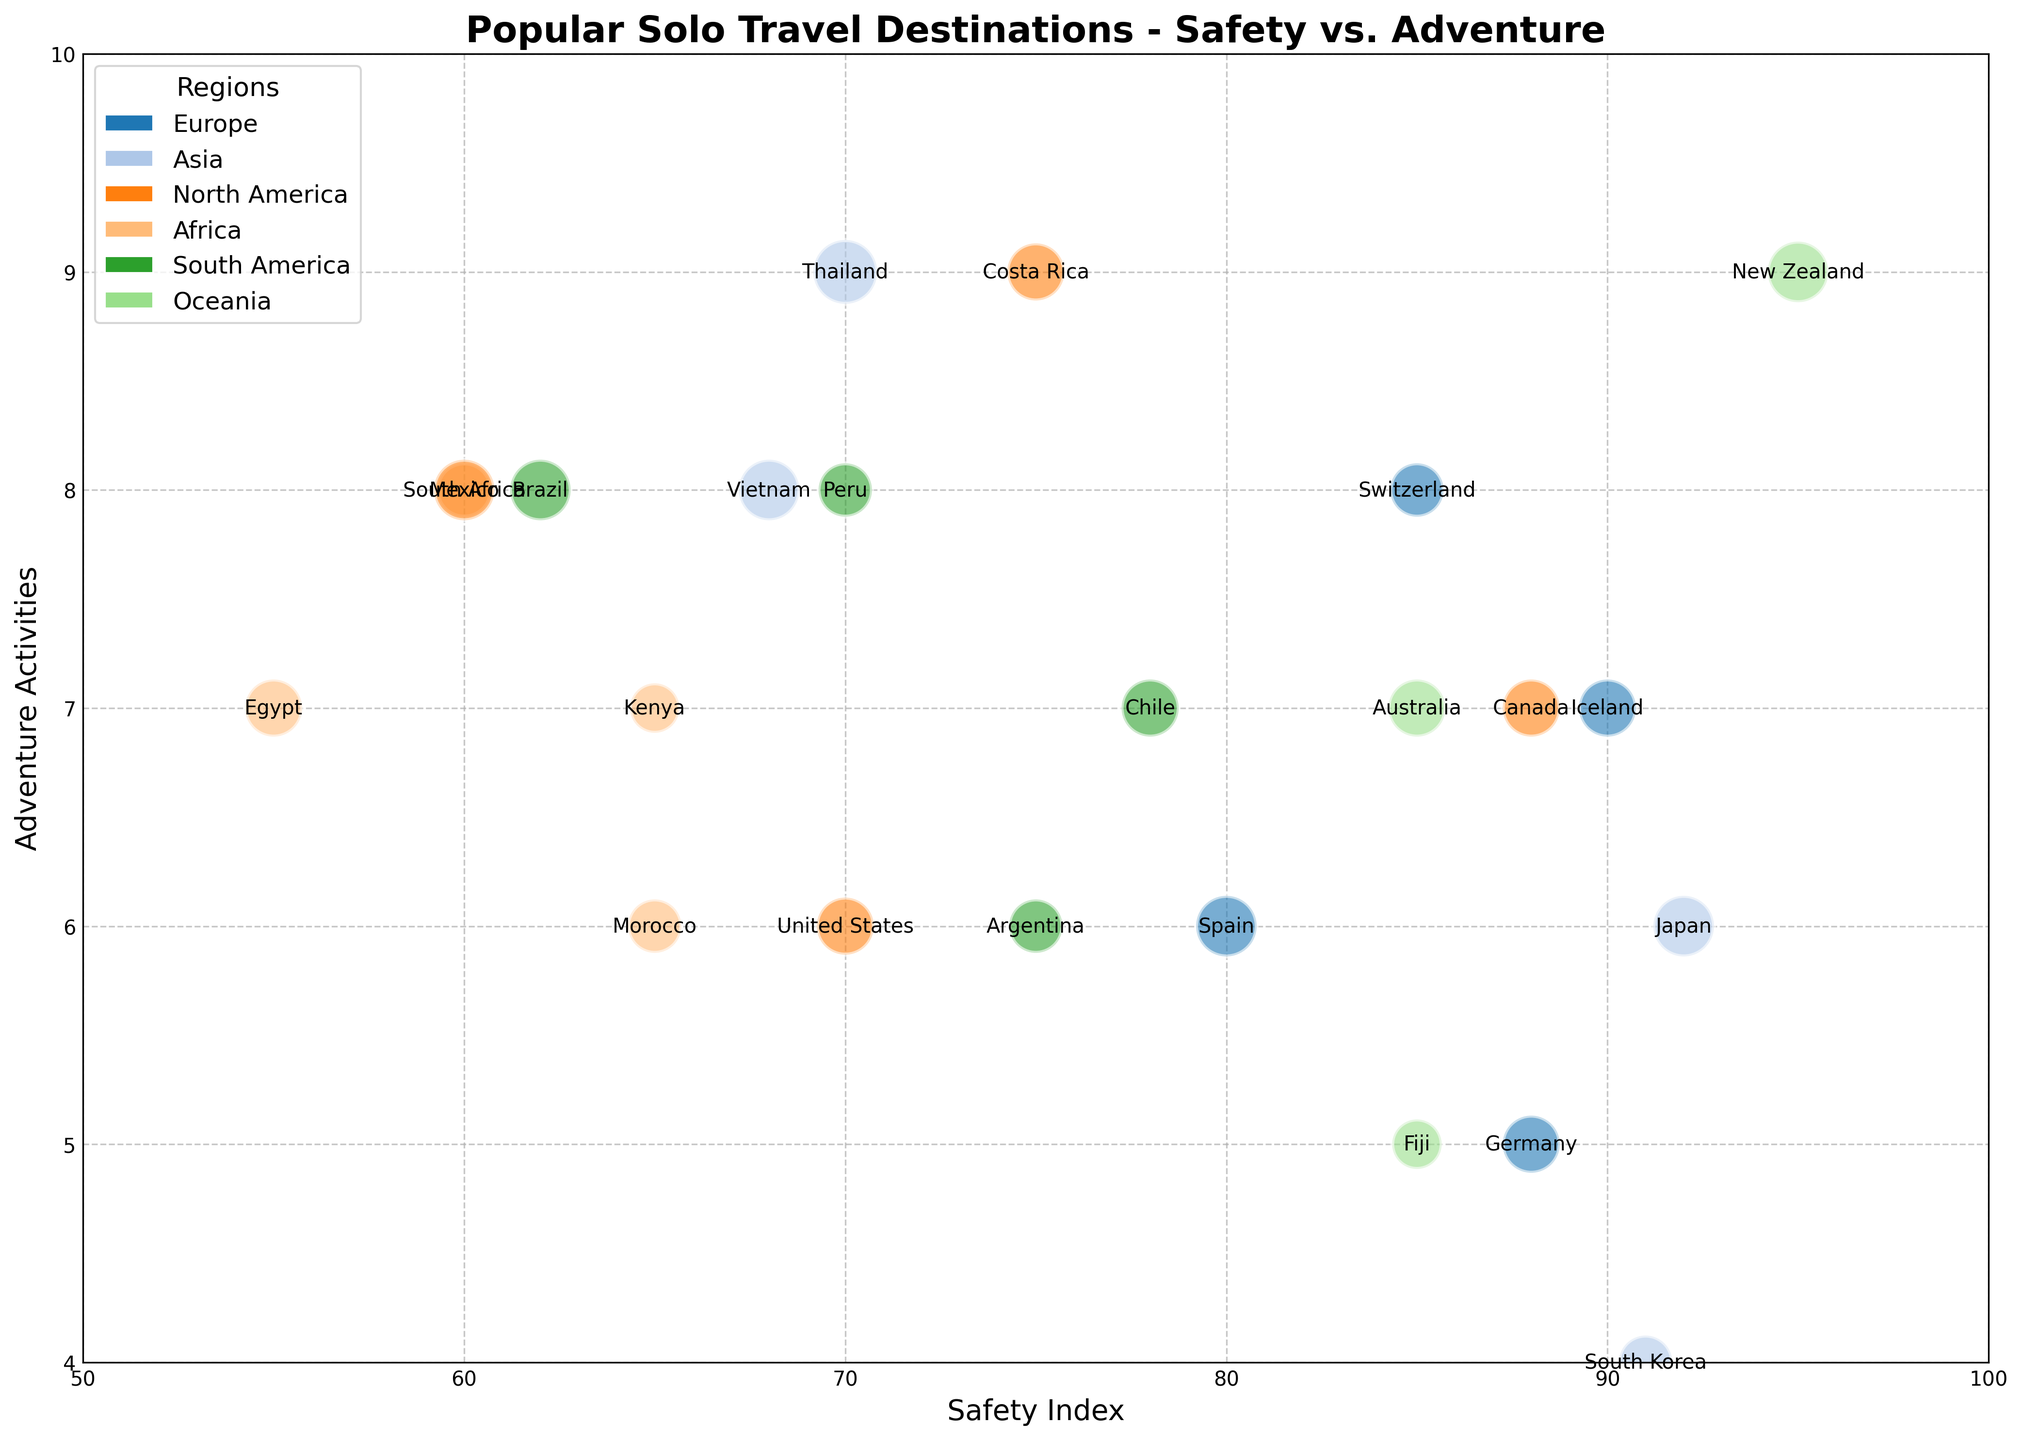What's the safest destination in North America? Look for the destination in North America with the highest safety index on the bubble chart. Canada has the highest safety index of 88 in North America.
Answer: Canada How many destinations have an adventure activities rating of 8? Count the bubbles that are positioned at the adventure activities value of 8. There are 6 destinations: Switzerland, South Africa, Peru, Thailand, Vietnam, and Brazil.
Answer: 6 Which region has the most destinations with high safety indexes (greater than 85)? Identify all the destinations with a safety index greater than 85 and count how many belong to each region. Europe has four destinations: Switzerland, Iceland, Germany, and Spain.
Answer: Europe Between Asia and Oceania, which region offers higher average adventure activities? Calculate the average adventure activities of destinations in Asia and Oceania. Asia has Japan (6), Thailand (9), South Korea (4), and Vietnam (8). Oceania has New Zealand (9), Australia (7), and Fiji (5). The average for Asia is (6+9+4+8)/4 = 6.75, and for Oceania is (9+7+5)/3 = 7. Oceania has a higher average.
Answer: Oceania What is the relationship between safety index and popularity for South Africa? Find the bubble for South Africa and note the safety index and popularity values. South Africa has a safety index of 60 and popularity rating has a moderate popular rating of 7.
Answer: South Africa: 60 safety, 7 popularity Which destination in Europe has the highest adventure activities rating? Check the adventure activities ratings for European destinations and find the highest value. Switzerland has the highest rating of 8.
Answer: Switzerland Which destination has the highest safety index and how many adventure activities does it have? Locate the destination with the highest safety index on the bubble chart. New Zealand has the highest safety index of 95 and an adventure activities rating of 9.
Answer: New Zealand, 9 What’s the major difference in adventure activities between Europe and South America? Compare the adventure activities of destinations in Europe and South America. Europe ranges from 5 to 8 while South America ranges from 6 to 8.
Answer: Europe: 5-8, South America: 6-8 Which destinations have the same safety index but belong to different regions? Find destinations with identical safety index values and check their regions. Morocco and Kenya both have a safety index of 65 but belong to Africa.
Answer: Morocco and Kenya 